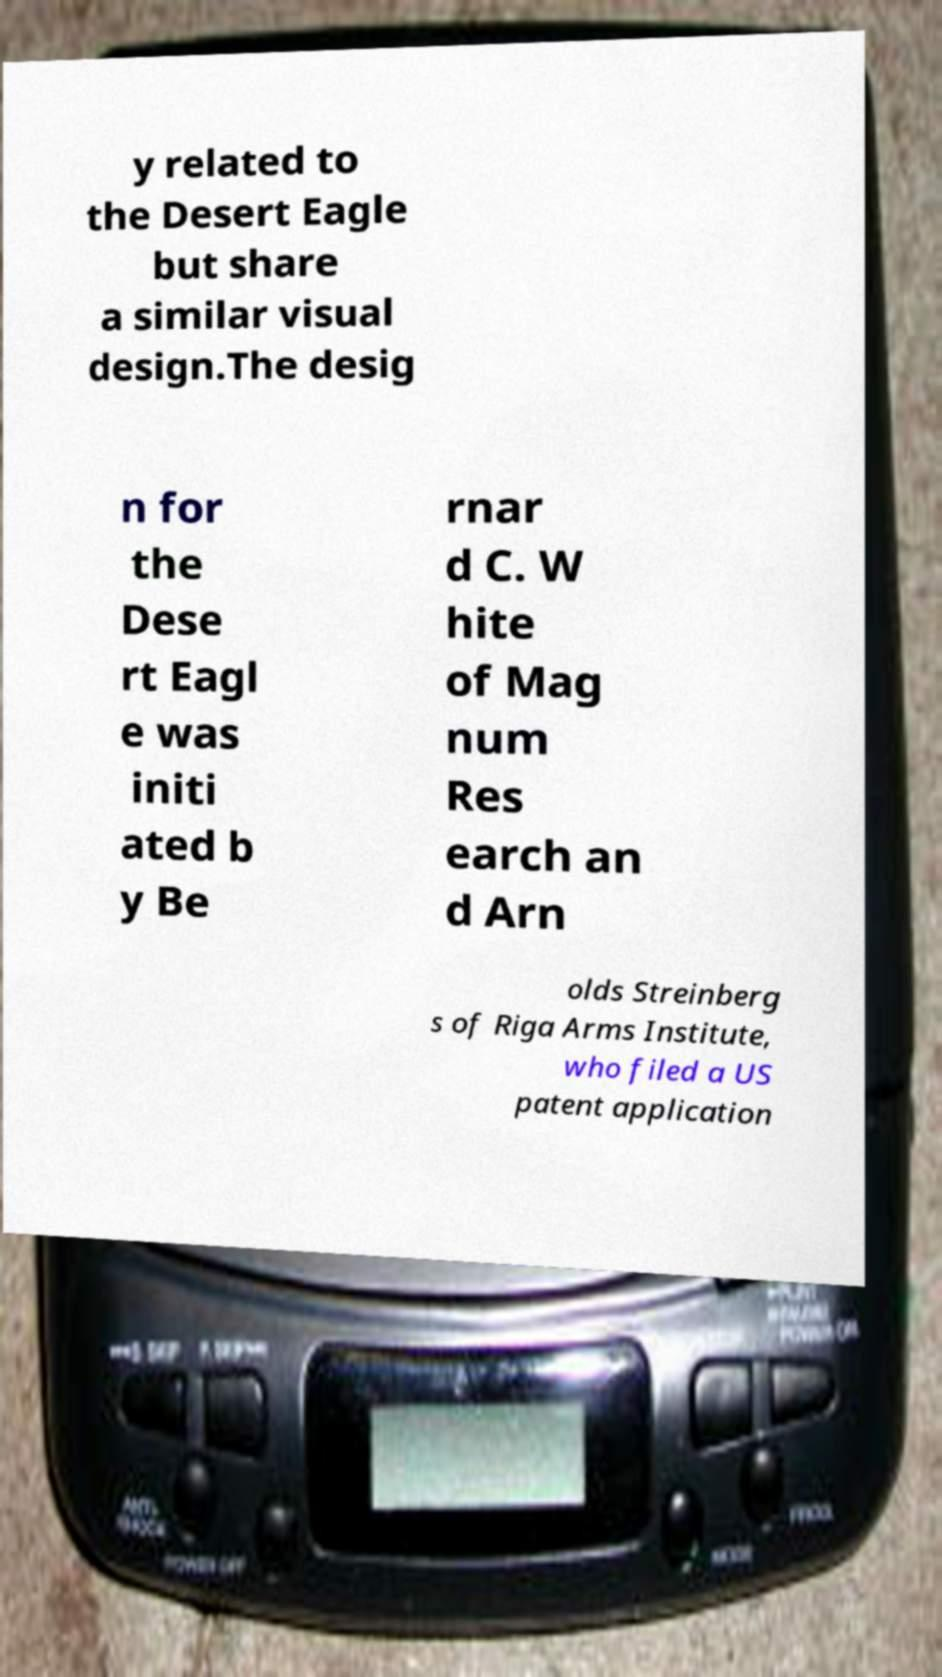Please identify and transcribe the text found in this image. y related to the Desert Eagle but share a similar visual design.The desig n for the Dese rt Eagl e was initi ated b y Be rnar d C. W hite of Mag num Res earch an d Arn olds Streinberg s of Riga Arms Institute, who filed a US patent application 